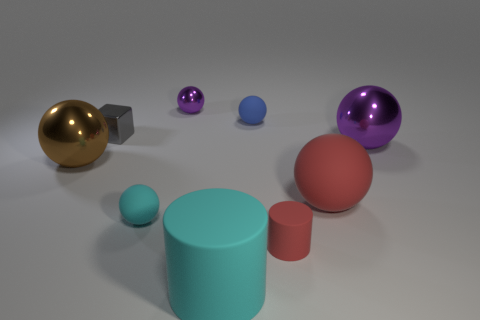What size is the cylinder that is the same color as the large rubber ball?
Keep it short and to the point. Small. How many spheres are behind the large red thing and in front of the large purple metallic ball?
Your response must be concise. 1. There is a blue thing that is made of the same material as the tiny red cylinder; what size is it?
Ensure brevity in your answer.  Small. What number of tiny cyan matte objects are the same shape as the brown metal object?
Offer a terse response. 1. Are there more shiny cubes on the right side of the small gray object than large cyan rubber things?
Make the answer very short. No. What shape is the thing that is both to the right of the small cyan matte object and to the left of the cyan rubber cylinder?
Your answer should be very brief. Sphere. Do the brown metallic thing and the gray thing have the same size?
Ensure brevity in your answer.  No. There is a metal block; what number of gray blocks are behind it?
Provide a short and direct response. 0. Are there an equal number of small rubber spheres in front of the red ball and small rubber things that are behind the small cube?
Offer a terse response. Yes. There is a small rubber thing that is behind the tiny block; is its shape the same as the big cyan object?
Ensure brevity in your answer.  No. 